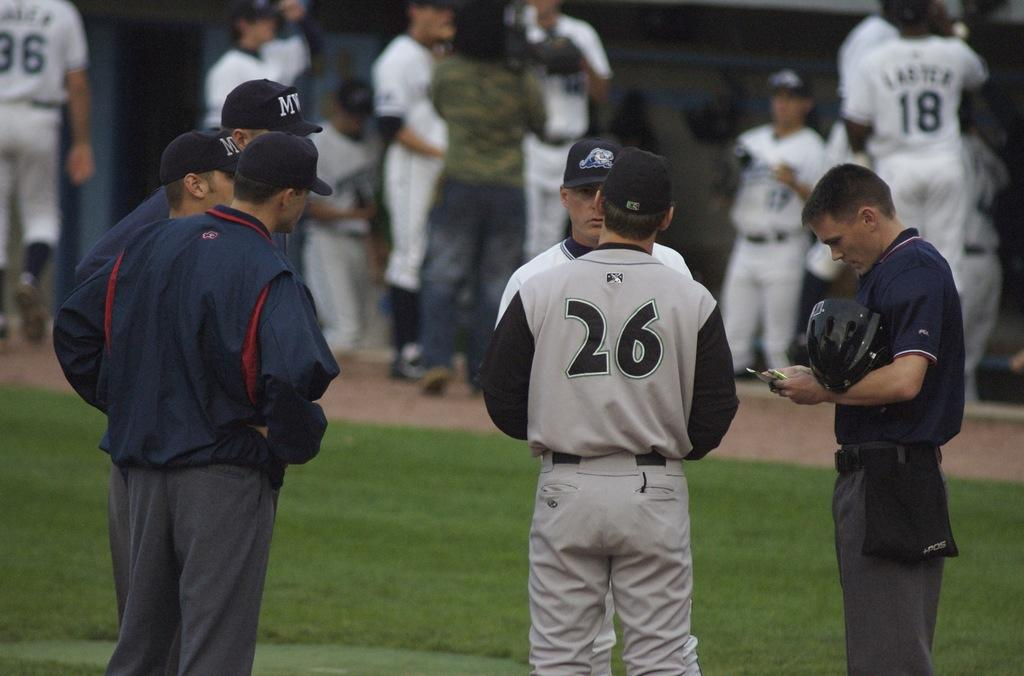<image>
Share a concise interpretation of the image provided. A baseball team on the field talking to the coaches and their jerseys have numbers on them and one says 26. 